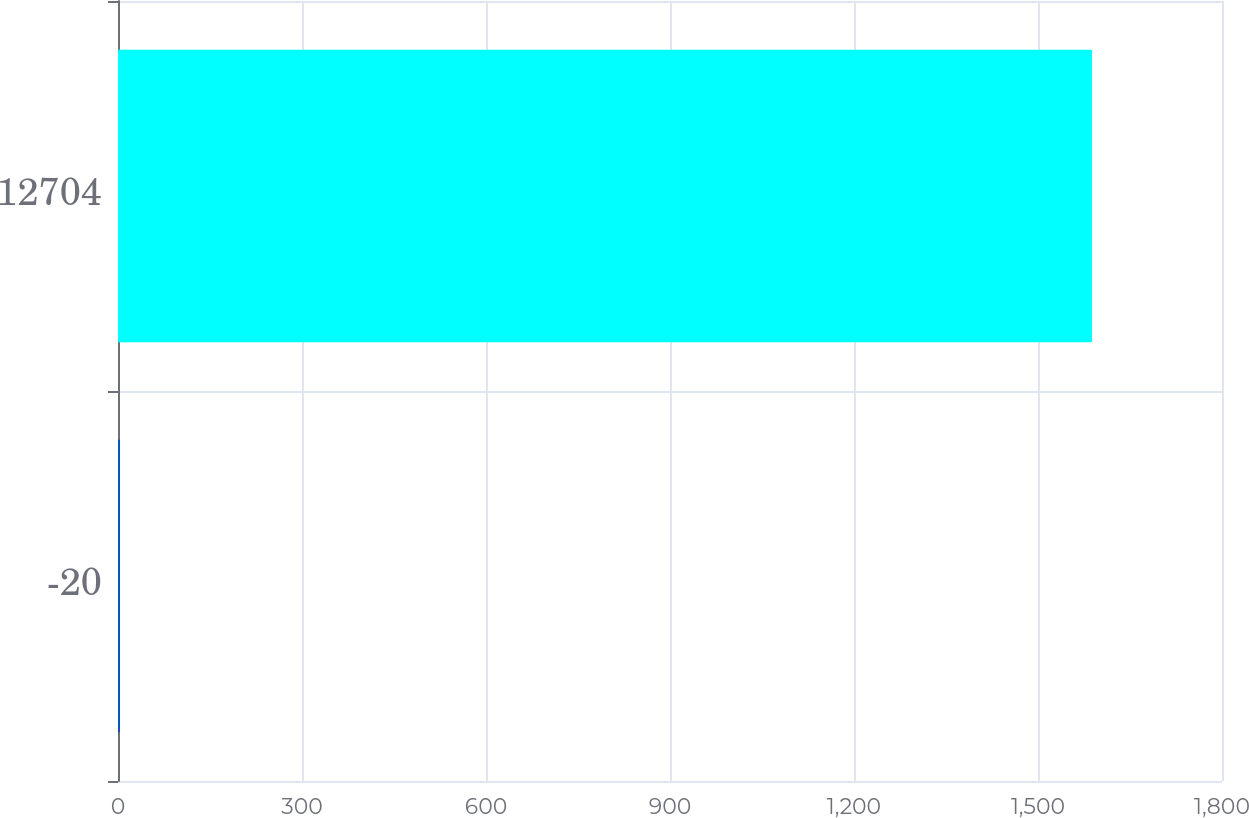Convert chart to OTSL. <chart><loc_0><loc_0><loc_500><loc_500><bar_chart><fcel>-20<fcel>12704<nl><fcel>3.3<fcel>1588<nl></chart> 